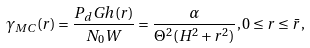Convert formula to latex. <formula><loc_0><loc_0><loc_500><loc_500>\gamma _ { M C } ( r ) = \frac { P _ { d } G h ( r ) } { N _ { 0 } W } = \frac { \alpha } { \Theta ^ { 2 } ( H ^ { 2 } + r ^ { 2 } ) } , 0 \leq r \leq \bar { r } ,</formula> 